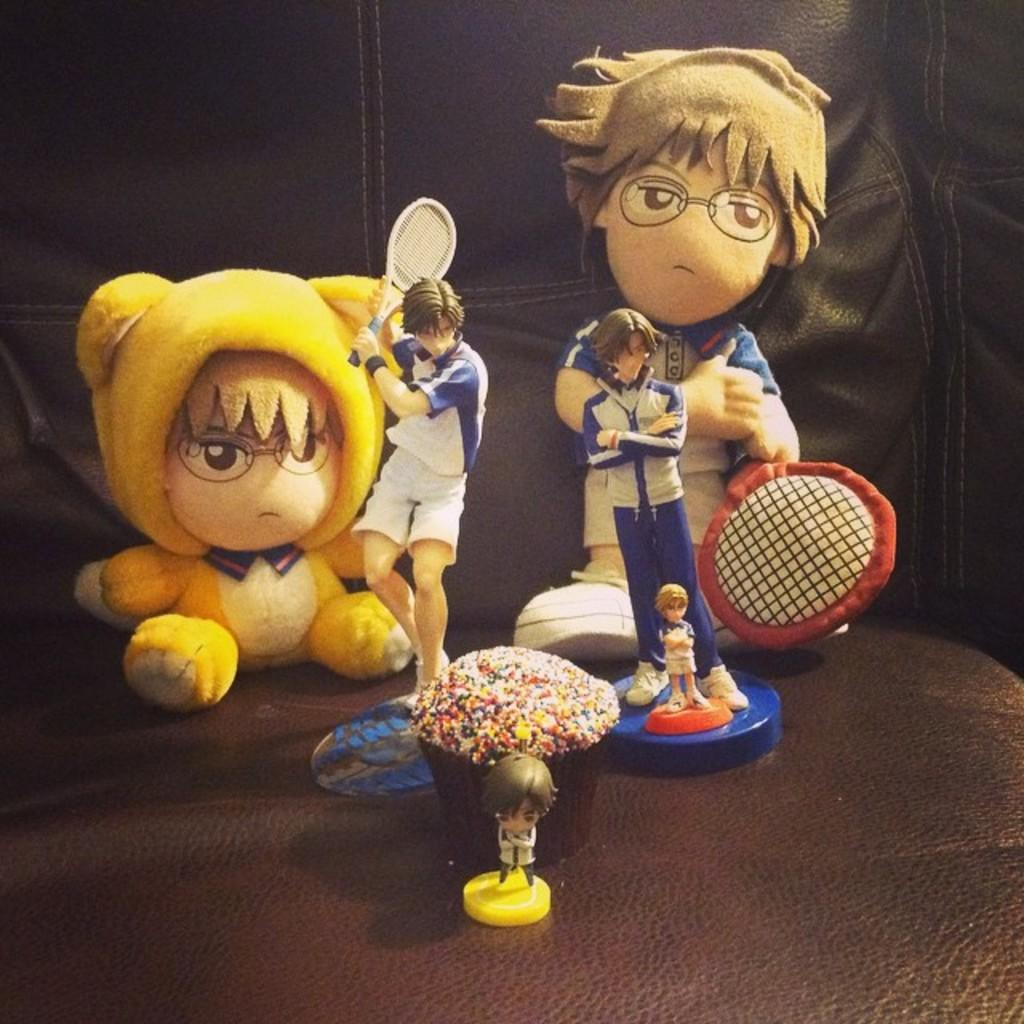What objects are on the sofa in the image? There are toys on a sofa in the image. Can you describe the setting where the toys are located? The image might have been taken in a room. What type of pen is the stranger holding in the image? There is no stranger or pen present in the image; it only features toys on a sofa in a room. 